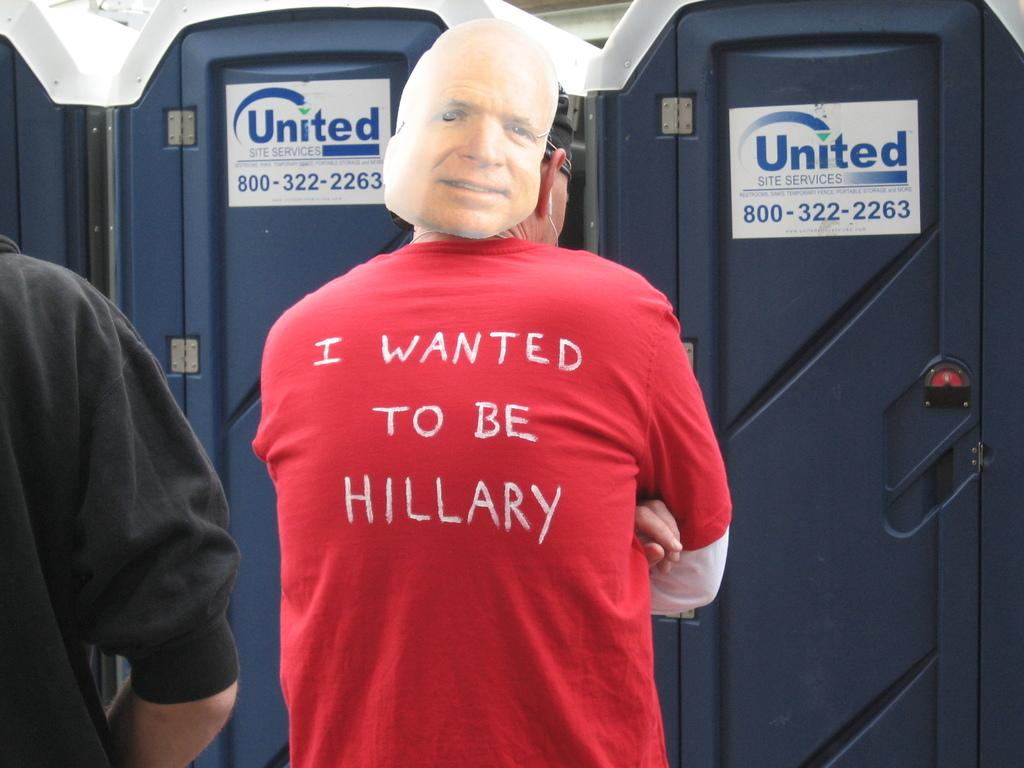Provide a one-sentence caption for the provided image. A man stands in front of United mobile restrooms wearing a shirt that says "I wanted to be Hillary.". 